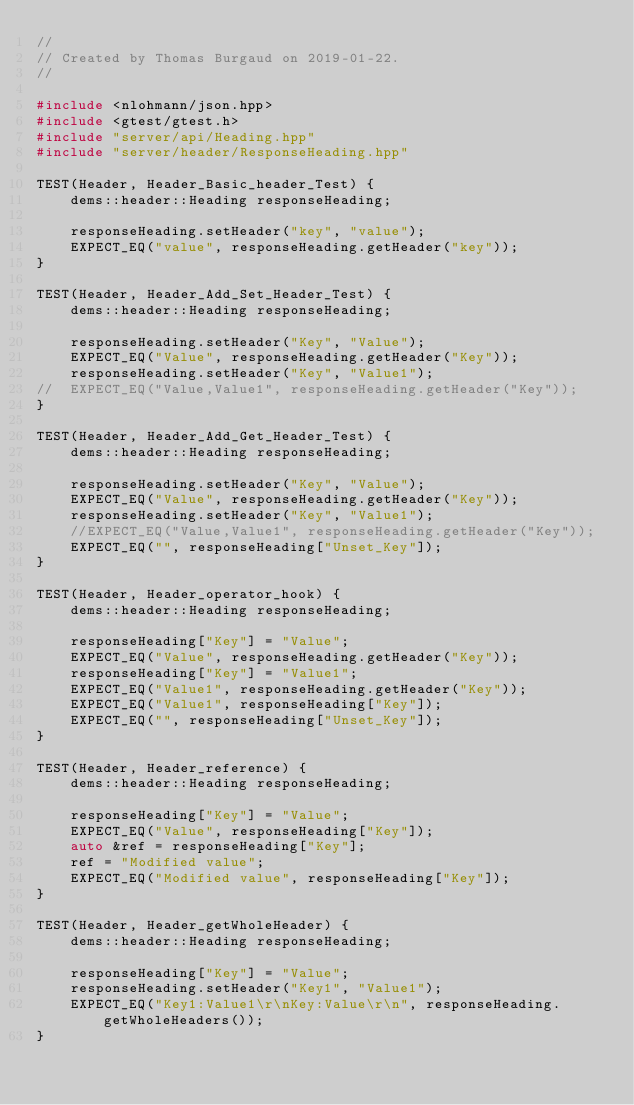Convert code to text. <code><loc_0><loc_0><loc_500><loc_500><_C++_>//
// Created by Thomas Burgaud on 2019-01-22.
//

#include <nlohmann/json.hpp>
#include <gtest/gtest.h>
#include "server/api/Heading.hpp"
#include "server/header/ResponseHeading.hpp"

TEST(Header, Header_Basic_header_Test) {
	dems::header::Heading responseHeading;

	responseHeading.setHeader("key", "value");
	EXPECT_EQ("value", responseHeading.getHeader("key"));
}

TEST(Header, Header_Add_Set_Header_Test) {
	dems::header::Heading responseHeading;

	responseHeading.setHeader("Key", "Value");
	EXPECT_EQ("Value", responseHeading.getHeader("Key"));
	responseHeading.setHeader("Key", "Value1");
//	EXPECT_EQ("Value,Value1", responseHeading.getHeader("Key"));
}

TEST(Header, Header_Add_Get_Header_Test) {
	dems::header::Heading responseHeading;

	responseHeading.setHeader("Key", "Value");
	EXPECT_EQ("Value", responseHeading.getHeader("Key"));
	responseHeading.setHeader("Key", "Value1");
	//EXPECT_EQ("Value,Value1", responseHeading.getHeader("Key"));
	EXPECT_EQ("", responseHeading["Unset_Key"]);
}

TEST(Header, Header_operator_hook) {
	dems::header::Heading responseHeading;

	responseHeading["Key"] = "Value";
	EXPECT_EQ("Value", responseHeading.getHeader("Key"));
	responseHeading["Key"] = "Value1";
	EXPECT_EQ("Value1", responseHeading.getHeader("Key"));
	EXPECT_EQ("Value1", responseHeading["Key"]);
	EXPECT_EQ("", responseHeading["Unset_Key"]);
}

TEST(Header, Header_reference) {
	dems::header::Heading responseHeading;

	responseHeading["Key"] = "Value";
	EXPECT_EQ("Value", responseHeading["Key"]);
	auto &ref = responseHeading["Key"];
	ref = "Modified value";
	EXPECT_EQ("Modified value", responseHeading["Key"]);
}

TEST(Header, Header_getWholeHeader) {
	dems::header::Heading responseHeading;

	responseHeading["Key"] = "Value";
	responseHeading.setHeader("Key1", "Value1");
	EXPECT_EQ("Key1:Value1\r\nKey:Value\r\n", responseHeading.getWholeHeaders());
}
</code> 